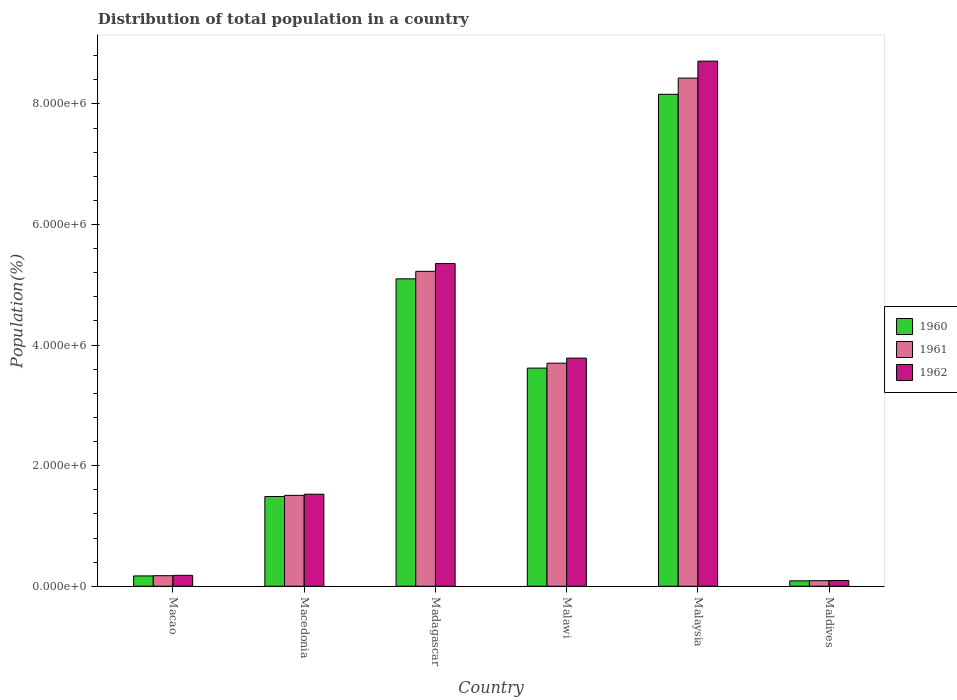How many different coloured bars are there?
Offer a terse response. 3. How many groups of bars are there?
Make the answer very short. 6. How many bars are there on the 1st tick from the right?
Provide a short and direct response. 3. What is the label of the 2nd group of bars from the left?
Your answer should be compact. Macedonia. What is the population of in 1962 in Malaysia?
Make the answer very short. 8.71e+06. Across all countries, what is the maximum population of in 1960?
Offer a very short reply. 8.16e+06. Across all countries, what is the minimum population of in 1961?
Provide a succinct answer. 9.23e+04. In which country was the population of in 1960 maximum?
Keep it short and to the point. Malaysia. In which country was the population of in 1961 minimum?
Provide a short and direct response. Maldives. What is the total population of in 1960 in the graph?
Keep it short and to the point. 1.86e+07. What is the difference between the population of in 1960 in Macao and that in Macedonia?
Keep it short and to the point. -1.32e+06. What is the difference between the population of in 1961 in Macedonia and the population of in 1962 in Madagascar?
Keep it short and to the point. -3.85e+06. What is the average population of in 1962 per country?
Provide a short and direct response. 3.28e+06. What is the difference between the population of of/in 1960 and population of of/in 1961 in Madagascar?
Make the answer very short. -1.24e+05. What is the ratio of the population of in 1960 in Madagascar to that in Malaysia?
Your answer should be very brief. 0.62. What is the difference between the highest and the second highest population of in 1962?
Offer a terse response. 1.57e+06. What is the difference between the highest and the lowest population of in 1960?
Offer a terse response. 8.07e+06. In how many countries, is the population of in 1962 greater than the average population of in 1962 taken over all countries?
Keep it short and to the point. 3. What does the 2nd bar from the left in Maldives represents?
Your response must be concise. 1961. What does the 1st bar from the right in Madagascar represents?
Provide a short and direct response. 1962. How many bars are there?
Keep it short and to the point. 18. Are all the bars in the graph horizontal?
Provide a succinct answer. No. What is the difference between two consecutive major ticks on the Y-axis?
Ensure brevity in your answer.  2.00e+06. Does the graph contain grids?
Provide a succinct answer. No. How many legend labels are there?
Provide a succinct answer. 3. What is the title of the graph?
Offer a terse response. Distribution of total population in a country. Does "1962" appear as one of the legend labels in the graph?
Offer a very short reply. Yes. What is the label or title of the Y-axis?
Keep it short and to the point. Population(%). What is the Population(%) in 1960 in Macao?
Give a very brief answer. 1.71e+05. What is the Population(%) of 1961 in Macao?
Provide a short and direct response. 1.75e+05. What is the Population(%) of 1962 in Macao?
Provide a succinct answer. 1.81e+05. What is the Population(%) of 1960 in Macedonia?
Offer a very short reply. 1.49e+06. What is the Population(%) in 1961 in Macedonia?
Keep it short and to the point. 1.51e+06. What is the Population(%) in 1962 in Macedonia?
Provide a succinct answer. 1.53e+06. What is the Population(%) of 1960 in Madagascar?
Provide a succinct answer. 5.10e+06. What is the Population(%) in 1961 in Madagascar?
Offer a very short reply. 5.22e+06. What is the Population(%) in 1962 in Madagascar?
Make the answer very short. 5.35e+06. What is the Population(%) of 1960 in Malawi?
Your answer should be very brief. 3.62e+06. What is the Population(%) of 1961 in Malawi?
Make the answer very short. 3.70e+06. What is the Population(%) in 1962 in Malawi?
Provide a succinct answer. 3.78e+06. What is the Population(%) of 1960 in Malaysia?
Ensure brevity in your answer.  8.16e+06. What is the Population(%) in 1961 in Malaysia?
Offer a terse response. 8.43e+06. What is the Population(%) in 1962 in Malaysia?
Keep it short and to the point. 8.71e+06. What is the Population(%) of 1960 in Maldives?
Keep it short and to the point. 8.99e+04. What is the Population(%) of 1961 in Maldives?
Your response must be concise. 9.23e+04. What is the Population(%) in 1962 in Maldives?
Offer a very short reply. 9.49e+04. Across all countries, what is the maximum Population(%) in 1960?
Give a very brief answer. 8.16e+06. Across all countries, what is the maximum Population(%) in 1961?
Make the answer very short. 8.43e+06. Across all countries, what is the maximum Population(%) of 1962?
Your answer should be compact. 8.71e+06. Across all countries, what is the minimum Population(%) in 1960?
Offer a very short reply. 8.99e+04. Across all countries, what is the minimum Population(%) of 1961?
Provide a succinct answer. 9.23e+04. Across all countries, what is the minimum Population(%) of 1962?
Offer a terse response. 9.49e+04. What is the total Population(%) of 1960 in the graph?
Offer a terse response. 1.86e+07. What is the total Population(%) in 1961 in the graph?
Your answer should be compact. 1.91e+07. What is the total Population(%) of 1962 in the graph?
Give a very brief answer. 1.97e+07. What is the difference between the Population(%) in 1960 in Macao and that in Macedonia?
Keep it short and to the point. -1.32e+06. What is the difference between the Population(%) in 1961 in Macao and that in Macedonia?
Make the answer very short. -1.33e+06. What is the difference between the Population(%) in 1962 in Macao and that in Macedonia?
Provide a short and direct response. -1.35e+06. What is the difference between the Population(%) in 1960 in Macao and that in Madagascar?
Offer a terse response. -4.93e+06. What is the difference between the Population(%) of 1961 in Macao and that in Madagascar?
Provide a succinct answer. -5.05e+06. What is the difference between the Population(%) in 1962 in Macao and that in Madagascar?
Make the answer very short. -5.17e+06. What is the difference between the Population(%) of 1960 in Macao and that in Malawi?
Offer a terse response. -3.45e+06. What is the difference between the Population(%) of 1961 in Macao and that in Malawi?
Your answer should be compact. -3.52e+06. What is the difference between the Population(%) in 1962 in Macao and that in Malawi?
Ensure brevity in your answer.  -3.60e+06. What is the difference between the Population(%) of 1960 in Macao and that in Malaysia?
Your answer should be compact. -7.99e+06. What is the difference between the Population(%) in 1961 in Macao and that in Malaysia?
Your answer should be compact. -8.25e+06. What is the difference between the Population(%) in 1962 in Macao and that in Malaysia?
Give a very brief answer. -8.53e+06. What is the difference between the Population(%) of 1960 in Macao and that in Maldives?
Offer a very short reply. 8.16e+04. What is the difference between the Population(%) of 1961 in Macao and that in Maldives?
Make the answer very short. 8.28e+04. What is the difference between the Population(%) in 1962 in Macao and that in Maldives?
Your response must be concise. 8.61e+04. What is the difference between the Population(%) in 1960 in Macedonia and that in Madagascar?
Make the answer very short. -3.61e+06. What is the difference between the Population(%) in 1961 in Macedonia and that in Madagascar?
Ensure brevity in your answer.  -3.72e+06. What is the difference between the Population(%) of 1962 in Macedonia and that in Madagascar?
Provide a short and direct response. -3.83e+06. What is the difference between the Population(%) of 1960 in Macedonia and that in Malawi?
Give a very brief answer. -2.13e+06. What is the difference between the Population(%) of 1961 in Macedonia and that in Malawi?
Give a very brief answer. -2.19e+06. What is the difference between the Population(%) of 1962 in Macedonia and that in Malawi?
Your answer should be very brief. -2.26e+06. What is the difference between the Population(%) in 1960 in Macedonia and that in Malaysia?
Your answer should be very brief. -6.67e+06. What is the difference between the Population(%) of 1961 in Macedonia and that in Malaysia?
Provide a succinct answer. -6.92e+06. What is the difference between the Population(%) in 1962 in Macedonia and that in Malaysia?
Ensure brevity in your answer.  -7.18e+06. What is the difference between the Population(%) in 1960 in Macedonia and that in Maldives?
Your answer should be very brief. 1.40e+06. What is the difference between the Population(%) in 1961 in Macedonia and that in Maldives?
Provide a short and direct response. 1.42e+06. What is the difference between the Population(%) in 1962 in Macedonia and that in Maldives?
Offer a very short reply. 1.43e+06. What is the difference between the Population(%) of 1960 in Madagascar and that in Malawi?
Make the answer very short. 1.48e+06. What is the difference between the Population(%) of 1961 in Madagascar and that in Malawi?
Offer a very short reply. 1.52e+06. What is the difference between the Population(%) of 1962 in Madagascar and that in Malawi?
Provide a succinct answer. 1.57e+06. What is the difference between the Population(%) of 1960 in Madagascar and that in Malaysia?
Provide a short and direct response. -3.06e+06. What is the difference between the Population(%) in 1961 in Madagascar and that in Malaysia?
Your response must be concise. -3.21e+06. What is the difference between the Population(%) of 1962 in Madagascar and that in Malaysia?
Keep it short and to the point. -3.36e+06. What is the difference between the Population(%) of 1960 in Madagascar and that in Maldives?
Make the answer very short. 5.01e+06. What is the difference between the Population(%) in 1961 in Madagascar and that in Maldives?
Give a very brief answer. 5.13e+06. What is the difference between the Population(%) of 1962 in Madagascar and that in Maldives?
Provide a succinct answer. 5.26e+06. What is the difference between the Population(%) of 1960 in Malawi and that in Malaysia?
Provide a succinct answer. -4.54e+06. What is the difference between the Population(%) of 1961 in Malawi and that in Malaysia?
Offer a very short reply. -4.73e+06. What is the difference between the Population(%) in 1962 in Malawi and that in Malaysia?
Make the answer very short. -4.93e+06. What is the difference between the Population(%) of 1960 in Malawi and that in Maldives?
Provide a succinct answer. 3.53e+06. What is the difference between the Population(%) in 1961 in Malawi and that in Maldives?
Offer a terse response. 3.61e+06. What is the difference between the Population(%) in 1962 in Malawi and that in Maldives?
Your answer should be very brief. 3.69e+06. What is the difference between the Population(%) of 1960 in Malaysia and that in Maldives?
Keep it short and to the point. 8.07e+06. What is the difference between the Population(%) of 1961 in Malaysia and that in Maldives?
Make the answer very short. 8.34e+06. What is the difference between the Population(%) in 1962 in Malaysia and that in Maldives?
Provide a short and direct response. 8.62e+06. What is the difference between the Population(%) in 1960 in Macao and the Population(%) in 1961 in Macedonia?
Your response must be concise. -1.34e+06. What is the difference between the Population(%) in 1960 in Macao and the Population(%) in 1962 in Macedonia?
Ensure brevity in your answer.  -1.36e+06. What is the difference between the Population(%) of 1961 in Macao and the Population(%) of 1962 in Macedonia?
Your answer should be very brief. -1.35e+06. What is the difference between the Population(%) of 1960 in Macao and the Population(%) of 1961 in Madagascar?
Keep it short and to the point. -5.05e+06. What is the difference between the Population(%) of 1960 in Macao and the Population(%) of 1962 in Madagascar?
Offer a very short reply. -5.18e+06. What is the difference between the Population(%) in 1961 in Macao and the Population(%) in 1962 in Madagascar?
Your response must be concise. -5.18e+06. What is the difference between the Population(%) of 1960 in Macao and the Population(%) of 1961 in Malawi?
Provide a short and direct response. -3.53e+06. What is the difference between the Population(%) of 1960 in Macao and the Population(%) of 1962 in Malawi?
Your response must be concise. -3.61e+06. What is the difference between the Population(%) of 1961 in Macao and the Population(%) of 1962 in Malawi?
Keep it short and to the point. -3.61e+06. What is the difference between the Population(%) of 1960 in Macao and the Population(%) of 1961 in Malaysia?
Ensure brevity in your answer.  -8.26e+06. What is the difference between the Population(%) in 1960 in Macao and the Population(%) in 1962 in Malaysia?
Your response must be concise. -8.54e+06. What is the difference between the Population(%) of 1961 in Macao and the Population(%) of 1962 in Malaysia?
Make the answer very short. -8.54e+06. What is the difference between the Population(%) in 1960 in Macao and the Population(%) in 1961 in Maldives?
Make the answer very short. 7.91e+04. What is the difference between the Population(%) of 1960 in Macao and the Population(%) of 1962 in Maldives?
Offer a very short reply. 7.65e+04. What is the difference between the Population(%) in 1961 in Macao and the Population(%) in 1962 in Maldives?
Offer a very short reply. 8.02e+04. What is the difference between the Population(%) in 1960 in Macedonia and the Population(%) in 1961 in Madagascar?
Your response must be concise. -3.73e+06. What is the difference between the Population(%) of 1960 in Macedonia and the Population(%) of 1962 in Madagascar?
Keep it short and to the point. -3.86e+06. What is the difference between the Population(%) of 1961 in Macedonia and the Population(%) of 1962 in Madagascar?
Give a very brief answer. -3.85e+06. What is the difference between the Population(%) in 1960 in Macedonia and the Population(%) in 1961 in Malawi?
Provide a succinct answer. -2.21e+06. What is the difference between the Population(%) in 1960 in Macedonia and the Population(%) in 1962 in Malawi?
Offer a very short reply. -2.30e+06. What is the difference between the Population(%) in 1961 in Macedonia and the Population(%) in 1962 in Malawi?
Provide a succinct answer. -2.28e+06. What is the difference between the Population(%) in 1960 in Macedonia and the Population(%) in 1961 in Malaysia?
Give a very brief answer. -6.94e+06. What is the difference between the Population(%) of 1960 in Macedonia and the Population(%) of 1962 in Malaysia?
Give a very brief answer. -7.22e+06. What is the difference between the Population(%) of 1961 in Macedonia and the Population(%) of 1962 in Malaysia?
Make the answer very short. -7.20e+06. What is the difference between the Population(%) of 1960 in Macedonia and the Population(%) of 1961 in Maldives?
Offer a terse response. 1.40e+06. What is the difference between the Population(%) of 1960 in Macedonia and the Population(%) of 1962 in Maldives?
Your response must be concise. 1.39e+06. What is the difference between the Population(%) in 1961 in Macedonia and the Population(%) in 1962 in Maldives?
Give a very brief answer. 1.41e+06. What is the difference between the Population(%) in 1960 in Madagascar and the Population(%) in 1961 in Malawi?
Ensure brevity in your answer.  1.40e+06. What is the difference between the Population(%) in 1960 in Madagascar and the Population(%) in 1962 in Malawi?
Keep it short and to the point. 1.31e+06. What is the difference between the Population(%) of 1961 in Madagascar and the Population(%) of 1962 in Malawi?
Offer a terse response. 1.44e+06. What is the difference between the Population(%) in 1960 in Madagascar and the Population(%) in 1961 in Malaysia?
Keep it short and to the point. -3.33e+06. What is the difference between the Population(%) in 1960 in Madagascar and the Population(%) in 1962 in Malaysia?
Your answer should be very brief. -3.61e+06. What is the difference between the Population(%) in 1961 in Madagascar and the Population(%) in 1962 in Malaysia?
Give a very brief answer. -3.49e+06. What is the difference between the Population(%) in 1960 in Madagascar and the Population(%) in 1961 in Maldives?
Your answer should be compact. 5.01e+06. What is the difference between the Population(%) in 1960 in Madagascar and the Population(%) in 1962 in Maldives?
Offer a terse response. 5.00e+06. What is the difference between the Population(%) of 1961 in Madagascar and the Population(%) of 1962 in Maldives?
Keep it short and to the point. 5.13e+06. What is the difference between the Population(%) in 1960 in Malawi and the Population(%) in 1961 in Malaysia?
Give a very brief answer. -4.81e+06. What is the difference between the Population(%) of 1960 in Malawi and the Population(%) of 1962 in Malaysia?
Make the answer very short. -5.09e+06. What is the difference between the Population(%) of 1961 in Malawi and the Population(%) of 1962 in Malaysia?
Your answer should be very brief. -5.01e+06. What is the difference between the Population(%) in 1960 in Malawi and the Population(%) in 1961 in Maldives?
Ensure brevity in your answer.  3.53e+06. What is the difference between the Population(%) of 1960 in Malawi and the Population(%) of 1962 in Maldives?
Offer a terse response. 3.52e+06. What is the difference between the Population(%) of 1961 in Malawi and the Population(%) of 1962 in Maldives?
Provide a succinct answer. 3.61e+06. What is the difference between the Population(%) of 1960 in Malaysia and the Population(%) of 1961 in Maldives?
Offer a very short reply. 8.07e+06. What is the difference between the Population(%) in 1960 in Malaysia and the Population(%) in 1962 in Maldives?
Provide a succinct answer. 8.07e+06. What is the difference between the Population(%) of 1961 in Malaysia and the Population(%) of 1962 in Maldives?
Make the answer very short. 8.33e+06. What is the average Population(%) of 1960 per country?
Give a very brief answer. 3.10e+06. What is the average Population(%) in 1961 per country?
Provide a succinct answer. 3.19e+06. What is the average Population(%) in 1962 per country?
Make the answer very short. 3.28e+06. What is the difference between the Population(%) of 1960 and Population(%) of 1961 in Macao?
Offer a very short reply. -3679. What is the difference between the Population(%) of 1960 and Population(%) of 1962 in Macao?
Ensure brevity in your answer.  -9569. What is the difference between the Population(%) in 1961 and Population(%) in 1962 in Macao?
Your response must be concise. -5890. What is the difference between the Population(%) of 1960 and Population(%) of 1961 in Macedonia?
Give a very brief answer. -1.90e+04. What is the difference between the Population(%) in 1960 and Population(%) in 1962 in Macedonia?
Offer a very short reply. -3.84e+04. What is the difference between the Population(%) in 1961 and Population(%) in 1962 in Macedonia?
Keep it short and to the point. -1.95e+04. What is the difference between the Population(%) of 1960 and Population(%) of 1961 in Madagascar?
Provide a succinct answer. -1.24e+05. What is the difference between the Population(%) in 1960 and Population(%) in 1962 in Madagascar?
Provide a succinct answer. -2.53e+05. What is the difference between the Population(%) in 1961 and Population(%) in 1962 in Madagascar?
Offer a terse response. -1.29e+05. What is the difference between the Population(%) of 1960 and Population(%) of 1961 in Malawi?
Give a very brief answer. -8.14e+04. What is the difference between the Population(%) in 1960 and Population(%) in 1962 in Malawi?
Your response must be concise. -1.66e+05. What is the difference between the Population(%) in 1961 and Population(%) in 1962 in Malawi?
Your answer should be compact. -8.44e+04. What is the difference between the Population(%) in 1960 and Population(%) in 1961 in Malaysia?
Ensure brevity in your answer.  -2.68e+05. What is the difference between the Population(%) in 1960 and Population(%) in 1962 in Malaysia?
Provide a succinct answer. -5.50e+05. What is the difference between the Population(%) in 1961 and Population(%) in 1962 in Malaysia?
Ensure brevity in your answer.  -2.81e+05. What is the difference between the Population(%) in 1960 and Population(%) in 1961 in Maldives?
Your answer should be compact. -2452. What is the difference between the Population(%) of 1960 and Population(%) of 1962 in Maldives?
Keep it short and to the point. -5034. What is the difference between the Population(%) in 1961 and Population(%) in 1962 in Maldives?
Give a very brief answer. -2582. What is the ratio of the Population(%) in 1960 in Macao to that in Macedonia?
Provide a succinct answer. 0.12. What is the ratio of the Population(%) in 1961 in Macao to that in Macedonia?
Provide a short and direct response. 0.12. What is the ratio of the Population(%) of 1962 in Macao to that in Macedonia?
Provide a short and direct response. 0.12. What is the ratio of the Population(%) of 1960 in Macao to that in Madagascar?
Offer a very short reply. 0.03. What is the ratio of the Population(%) of 1961 in Macao to that in Madagascar?
Your response must be concise. 0.03. What is the ratio of the Population(%) in 1962 in Macao to that in Madagascar?
Make the answer very short. 0.03. What is the ratio of the Population(%) in 1960 in Macao to that in Malawi?
Offer a very short reply. 0.05. What is the ratio of the Population(%) of 1961 in Macao to that in Malawi?
Your answer should be compact. 0.05. What is the ratio of the Population(%) of 1962 in Macao to that in Malawi?
Provide a short and direct response. 0.05. What is the ratio of the Population(%) of 1960 in Macao to that in Malaysia?
Your answer should be compact. 0.02. What is the ratio of the Population(%) of 1961 in Macao to that in Malaysia?
Offer a terse response. 0.02. What is the ratio of the Population(%) in 1962 in Macao to that in Malaysia?
Offer a very short reply. 0.02. What is the ratio of the Population(%) in 1960 in Macao to that in Maldives?
Your response must be concise. 1.91. What is the ratio of the Population(%) in 1961 in Macao to that in Maldives?
Keep it short and to the point. 1.9. What is the ratio of the Population(%) in 1962 in Macao to that in Maldives?
Offer a very short reply. 1.91. What is the ratio of the Population(%) of 1960 in Macedonia to that in Madagascar?
Your answer should be very brief. 0.29. What is the ratio of the Population(%) in 1961 in Macedonia to that in Madagascar?
Keep it short and to the point. 0.29. What is the ratio of the Population(%) of 1962 in Macedonia to that in Madagascar?
Your answer should be very brief. 0.29. What is the ratio of the Population(%) of 1960 in Macedonia to that in Malawi?
Provide a succinct answer. 0.41. What is the ratio of the Population(%) of 1961 in Macedonia to that in Malawi?
Provide a succinct answer. 0.41. What is the ratio of the Population(%) in 1962 in Macedonia to that in Malawi?
Ensure brevity in your answer.  0.4. What is the ratio of the Population(%) of 1960 in Macedonia to that in Malaysia?
Provide a succinct answer. 0.18. What is the ratio of the Population(%) in 1961 in Macedonia to that in Malaysia?
Keep it short and to the point. 0.18. What is the ratio of the Population(%) in 1962 in Macedonia to that in Malaysia?
Make the answer very short. 0.18. What is the ratio of the Population(%) in 1960 in Macedonia to that in Maldives?
Offer a very short reply. 16.56. What is the ratio of the Population(%) of 1961 in Macedonia to that in Maldives?
Your answer should be compact. 16.33. What is the ratio of the Population(%) of 1962 in Macedonia to that in Maldives?
Your answer should be very brief. 16.09. What is the ratio of the Population(%) of 1960 in Madagascar to that in Malawi?
Keep it short and to the point. 1.41. What is the ratio of the Population(%) of 1961 in Madagascar to that in Malawi?
Provide a succinct answer. 1.41. What is the ratio of the Population(%) of 1962 in Madagascar to that in Malawi?
Your answer should be compact. 1.41. What is the ratio of the Population(%) in 1960 in Madagascar to that in Malaysia?
Your response must be concise. 0.62. What is the ratio of the Population(%) of 1961 in Madagascar to that in Malaysia?
Give a very brief answer. 0.62. What is the ratio of the Population(%) of 1962 in Madagascar to that in Malaysia?
Your response must be concise. 0.61. What is the ratio of the Population(%) in 1960 in Madagascar to that in Maldives?
Your answer should be compact. 56.74. What is the ratio of the Population(%) in 1961 in Madagascar to that in Maldives?
Your answer should be compact. 56.58. What is the ratio of the Population(%) in 1962 in Madagascar to that in Maldives?
Provide a succinct answer. 56.4. What is the ratio of the Population(%) of 1960 in Malawi to that in Malaysia?
Offer a terse response. 0.44. What is the ratio of the Population(%) in 1961 in Malawi to that in Malaysia?
Give a very brief answer. 0.44. What is the ratio of the Population(%) in 1962 in Malawi to that in Malaysia?
Your response must be concise. 0.43. What is the ratio of the Population(%) in 1960 in Malawi to that in Maldives?
Provide a short and direct response. 40.26. What is the ratio of the Population(%) of 1961 in Malawi to that in Maldives?
Give a very brief answer. 40.08. What is the ratio of the Population(%) of 1962 in Malawi to that in Maldives?
Your answer should be compact. 39.87. What is the ratio of the Population(%) in 1960 in Malaysia to that in Maldives?
Offer a terse response. 90.8. What is the ratio of the Population(%) of 1961 in Malaysia to that in Maldives?
Your answer should be very brief. 91.3. What is the ratio of the Population(%) in 1962 in Malaysia to that in Maldives?
Your answer should be very brief. 91.78. What is the difference between the highest and the second highest Population(%) in 1960?
Your answer should be very brief. 3.06e+06. What is the difference between the highest and the second highest Population(%) in 1961?
Provide a succinct answer. 3.21e+06. What is the difference between the highest and the second highest Population(%) in 1962?
Your answer should be very brief. 3.36e+06. What is the difference between the highest and the lowest Population(%) in 1960?
Offer a very short reply. 8.07e+06. What is the difference between the highest and the lowest Population(%) of 1961?
Provide a short and direct response. 8.34e+06. What is the difference between the highest and the lowest Population(%) in 1962?
Provide a short and direct response. 8.62e+06. 